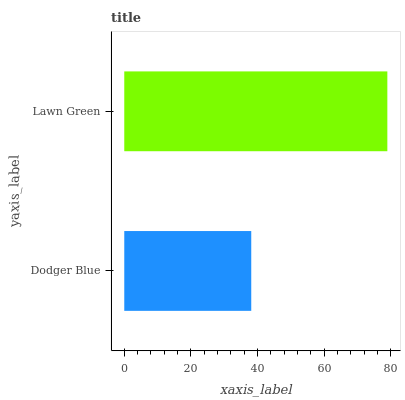Is Dodger Blue the minimum?
Answer yes or no. Yes. Is Lawn Green the maximum?
Answer yes or no. Yes. Is Lawn Green the minimum?
Answer yes or no. No. Is Lawn Green greater than Dodger Blue?
Answer yes or no. Yes. Is Dodger Blue less than Lawn Green?
Answer yes or no. Yes. Is Dodger Blue greater than Lawn Green?
Answer yes or no. No. Is Lawn Green less than Dodger Blue?
Answer yes or no. No. Is Lawn Green the high median?
Answer yes or no. Yes. Is Dodger Blue the low median?
Answer yes or no. Yes. Is Dodger Blue the high median?
Answer yes or no. No. Is Lawn Green the low median?
Answer yes or no. No. 